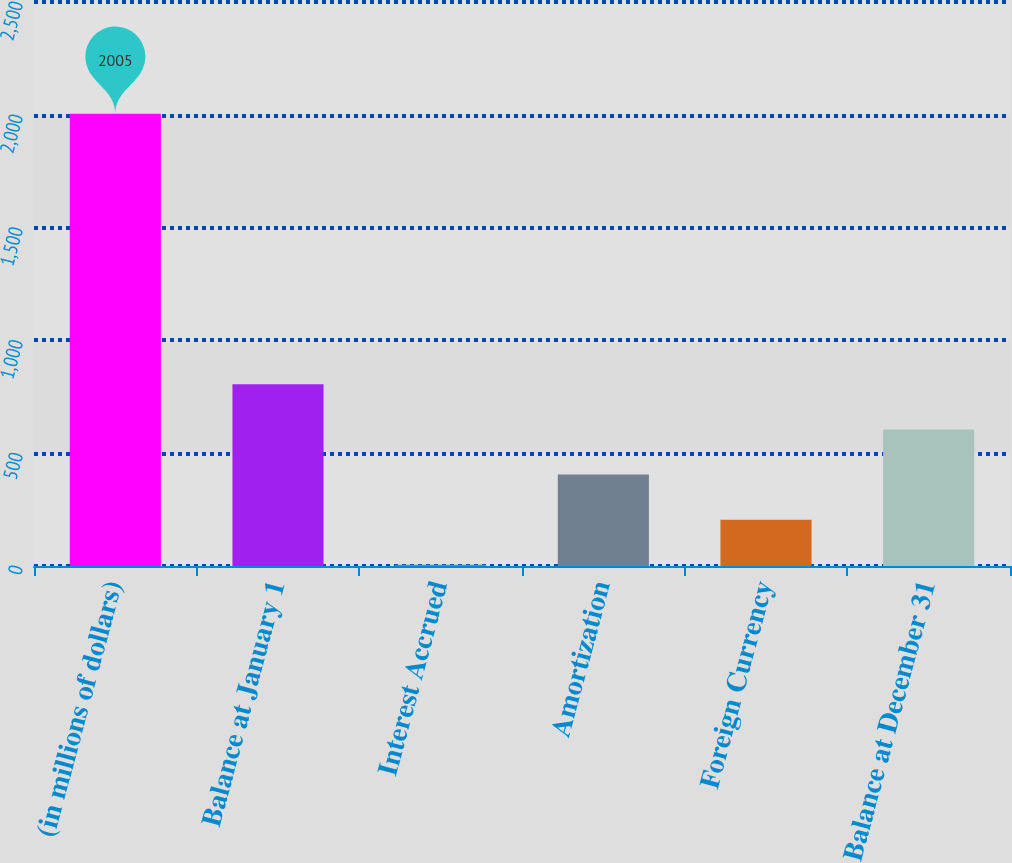<chart> <loc_0><loc_0><loc_500><loc_500><bar_chart><fcel>(in millions of dollars)<fcel>Balance at January 1<fcel>Interest Accrued<fcel>Amortization<fcel>Foreign Currency<fcel>Balance at December 31<nl><fcel>2005<fcel>805.12<fcel>5.2<fcel>405.16<fcel>205.18<fcel>605.14<nl></chart> 